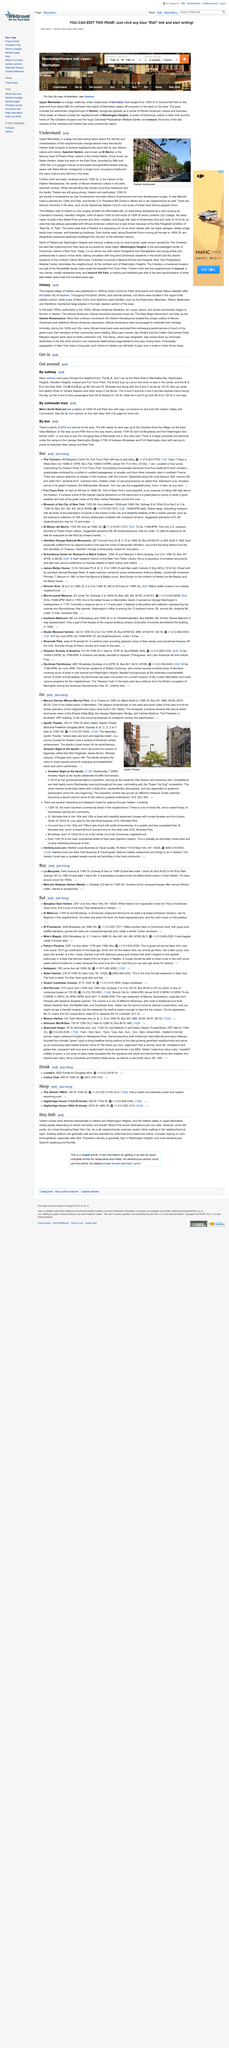Specify some key components in this picture. Spanish Harlem is bounded by 96th and 125th Streets. El Barrio, formerly known as Italian Harlem, was renowned for its strong Italian American community and cultural heritage. The original name of Harlem was Nieuw Haarlem. Spanish Harlem, also known as El Barrio, is a neighborhood located in Manhattan, New York City. There are two dot points included in the article. 